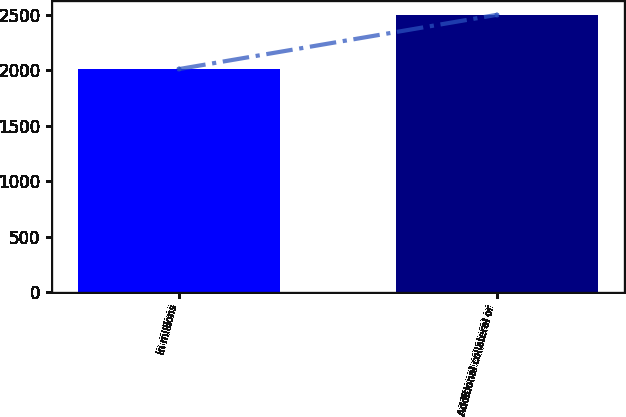Convert chart to OTSL. <chart><loc_0><loc_0><loc_500><loc_500><bar_chart><fcel>in millions<fcel>Additional collateral or<nl><fcel>2012<fcel>2500<nl></chart> 